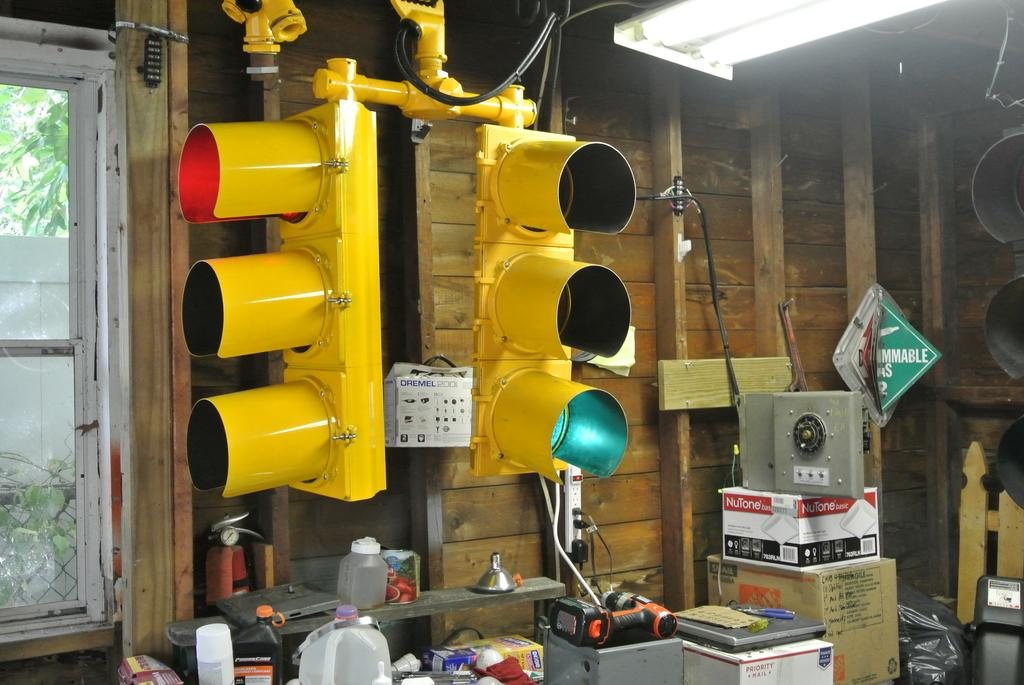What type of objects are used to control traffic in the image? There are traffic signals in the image. What can be seen through the window in the image? There is a wall and trees visible outside the window. What type of objects are present in the image that are typically used for storage? There are boxes in the image. What type of objects are present in the image that are typically used for holding liquids? There are bottles in the image. What is visible on the other side of the window in the image? A wall and trees are visible outside the window. What type of skin is visible on the trees outside the window in the image? There is no mention of skin on the trees in the image; only the presence of trees is noted. What type of wax is used to create the traffic signals in the image? There is no mention of wax being used to create the traffic signals in the image. 